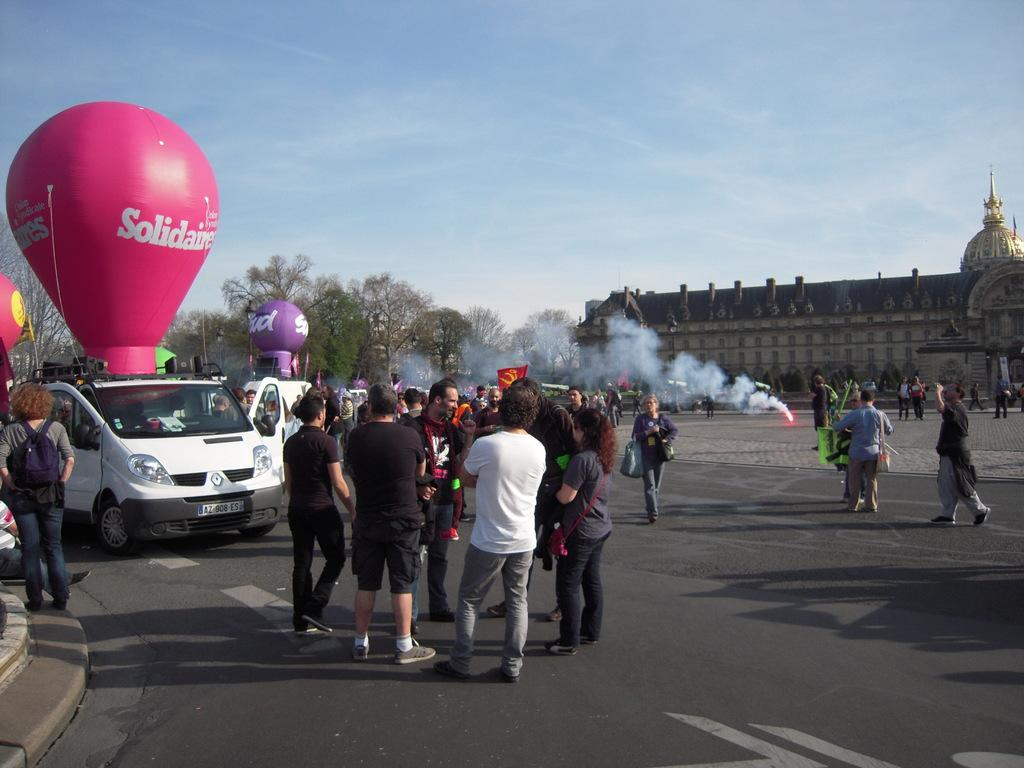What are the people in the image doing? There is a group of people standing on the road in the image. What can be seen in the background of the image? There is a building visible in the image, as well as trees. What is the color of the sky in the image? The sky is blue in the image. What additional object is present in the image? There is a gas balloon in the image. What type of vehicle is parked on the road? A vehicle is parked on the road in the image. Can you tell me how many bricks are used to build the partner's house in the image? There is no mention of a partner or a house in the image, and therefore no information about bricks can be provided. 